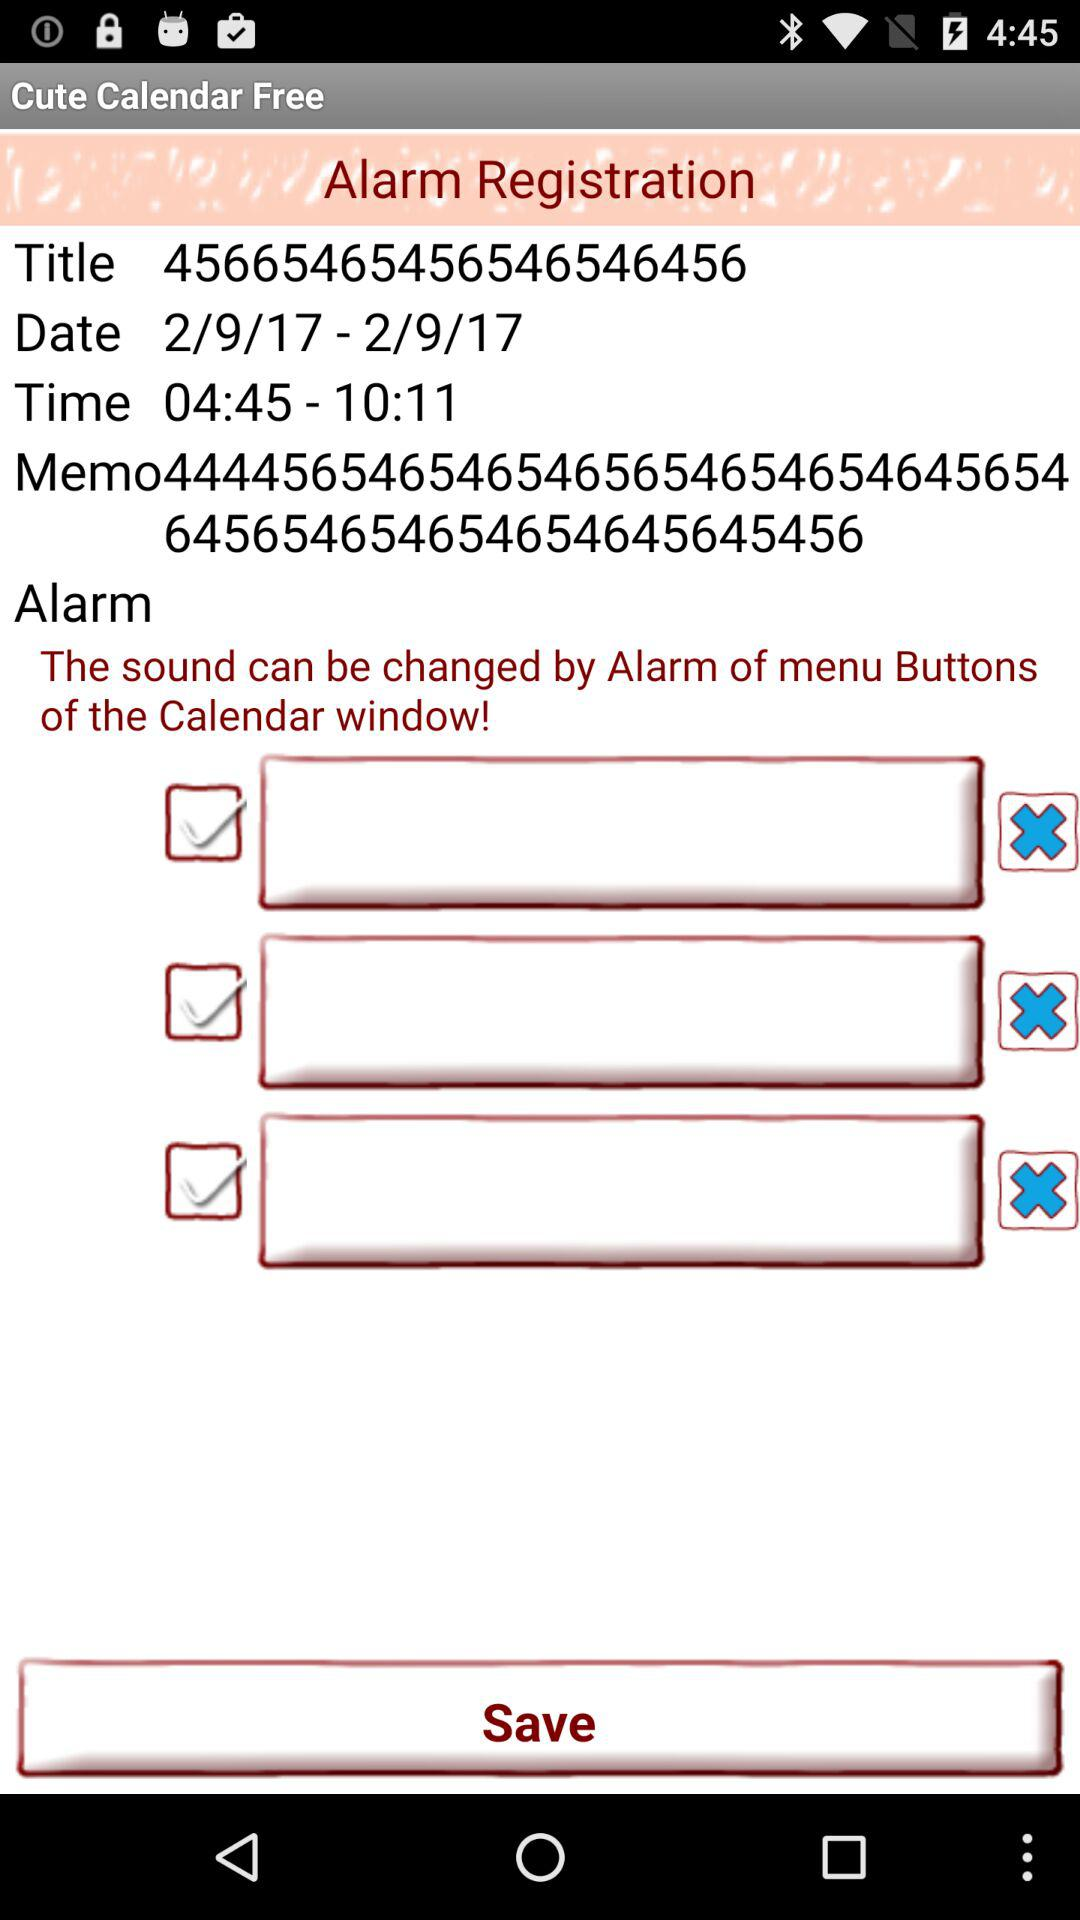What is the title of the alarm registration? The title of the alarm registration is "45665465456546546456". 